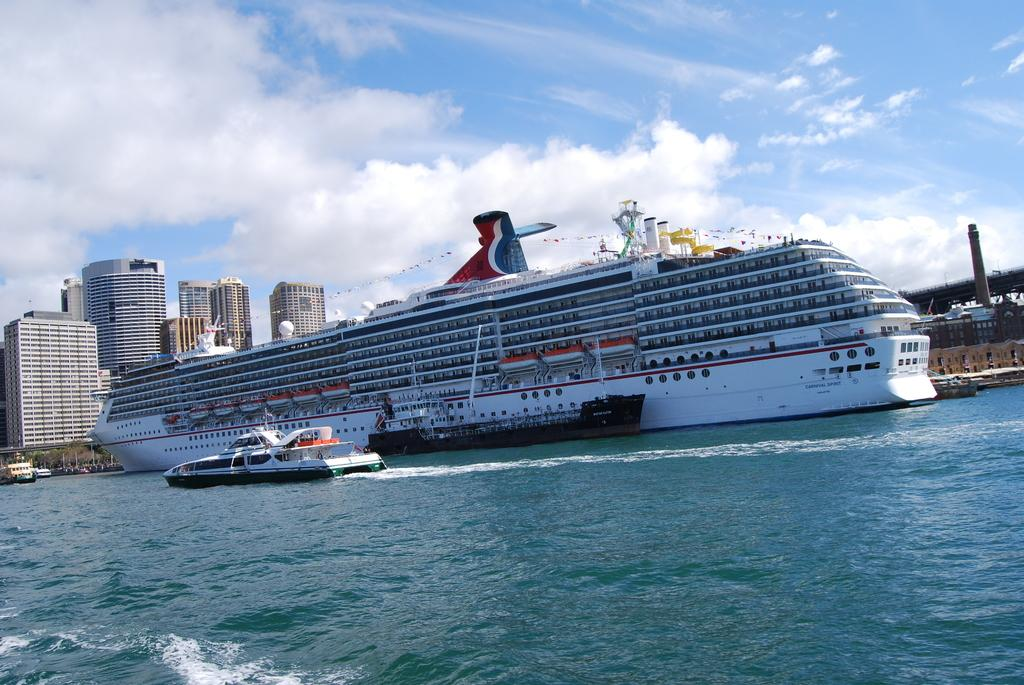What type of vehicles can be seen in the image? There are ships in the image. What structures are present in the image? There are buildings in the image. What natural element is visible in the image? Water is visible in the image. What part of the environment is visible in the image? The sky is visible in the image. What type of coal is being used to power the tramp in the image? There is no tramp present in the image, and coal is not mentioned as a power source for any of the visible elements. 